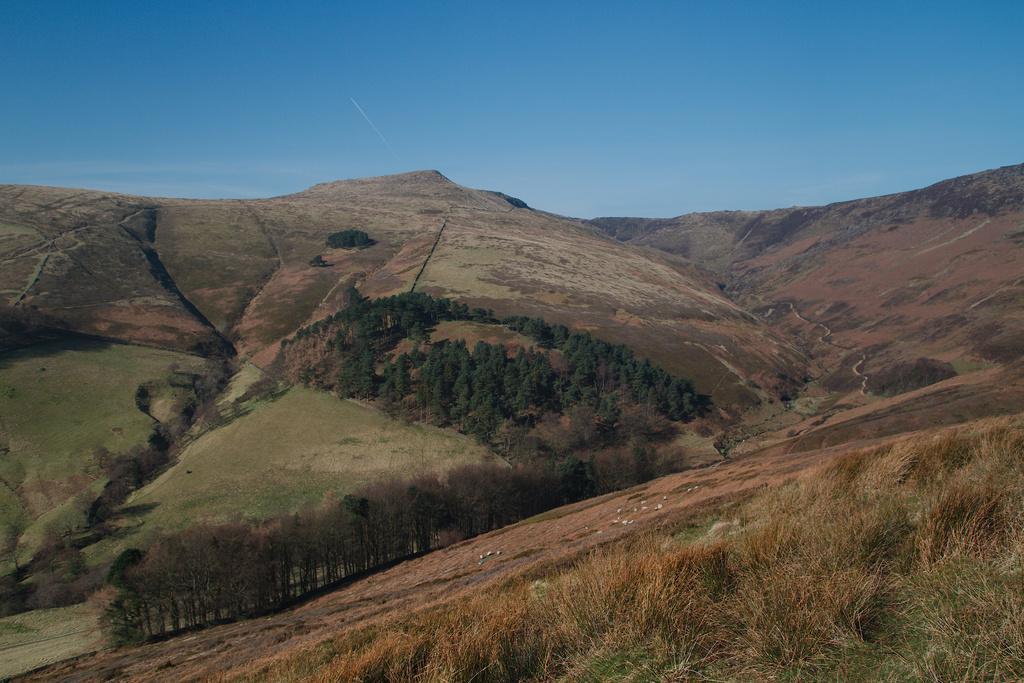In one or two sentences, can you explain what this image depicts? In this image there is the sky, there are mountains, there are trees on the mountains, there is grass. 